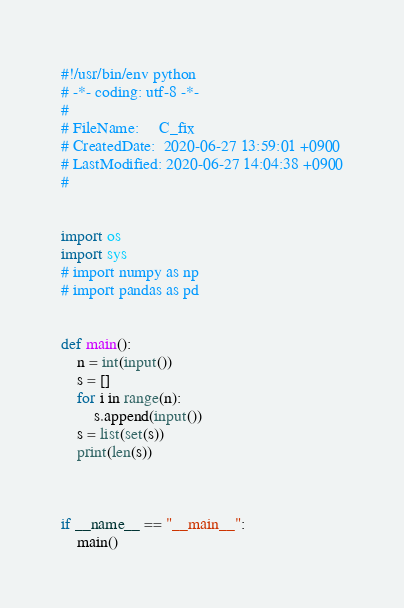<code> <loc_0><loc_0><loc_500><loc_500><_Python_>#!/usr/bin/env python
# -*- coding: utf-8 -*-
#
# FileName: 	C_fix
# CreatedDate:  2020-06-27 13:59:01 +0900
# LastModified: 2020-06-27 14:04:38 +0900
#


import os
import sys
# import numpy as np
# import pandas as pd


def main():
    n = int(input())
    s = []
    for i in range(n):
        s.append(input())
    s = list(set(s))
    print(len(s))
        


if __name__ == "__main__":
    main()
</code> 